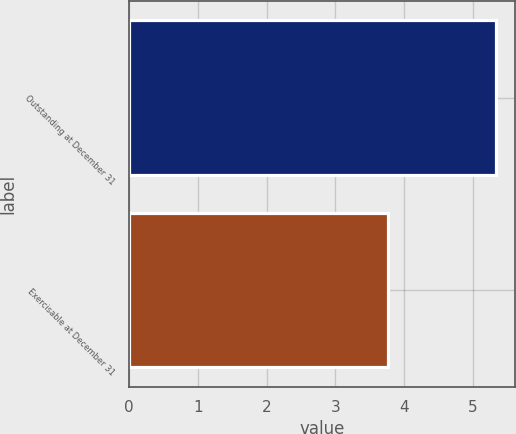Convert chart. <chart><loc_0><loc_0><loc_500><loc_500><bar_chart><fcel>Outstanding at December 31<fcel>Exercisable at December 31<nl><fcel>5.34<fcel>3.77<nl></chart> 